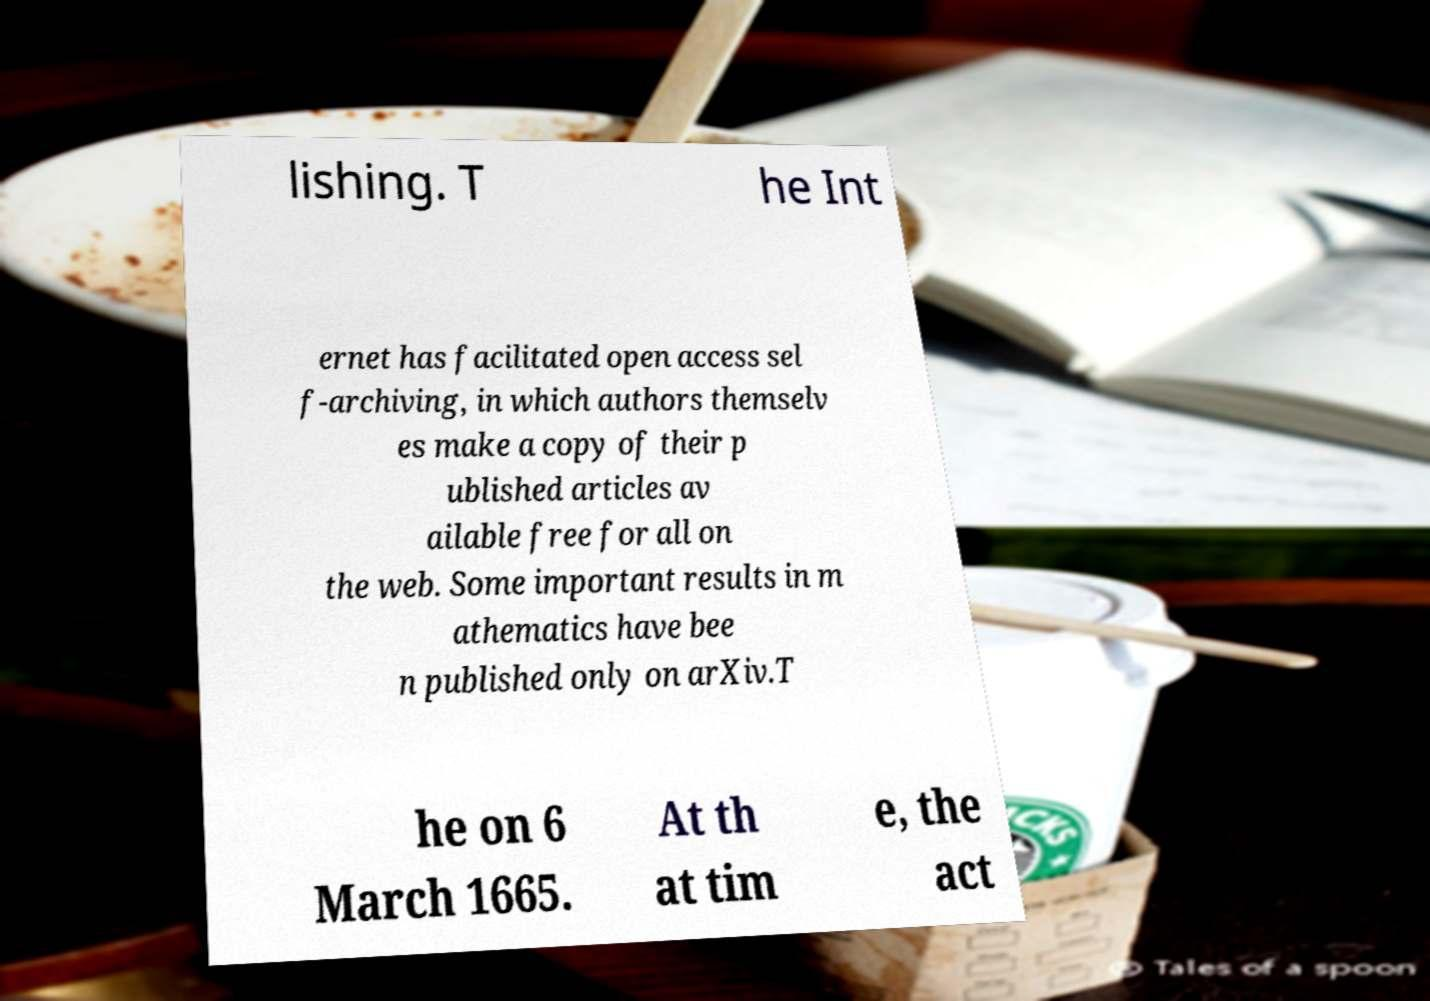Can you read and provide the text displayed in the image?This photo seems to have some interesting text. Can you extract and type it out for me? lishing. T he Int ernet has facilitated open access sel f-archiving, in which authors themselv es make a copy of their p ublished articles av ailable free for all on the web. Some important results in m athematics have bee n published only on arXiv.T he on 6 March 1665. At th at tim e, the act 